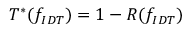<formula> <loc_0><loc_0><loc_500><loc_500>T ^ { * } ( f _ { I D T } ) = 1 - R ( f _ { I D T } )</formula> 